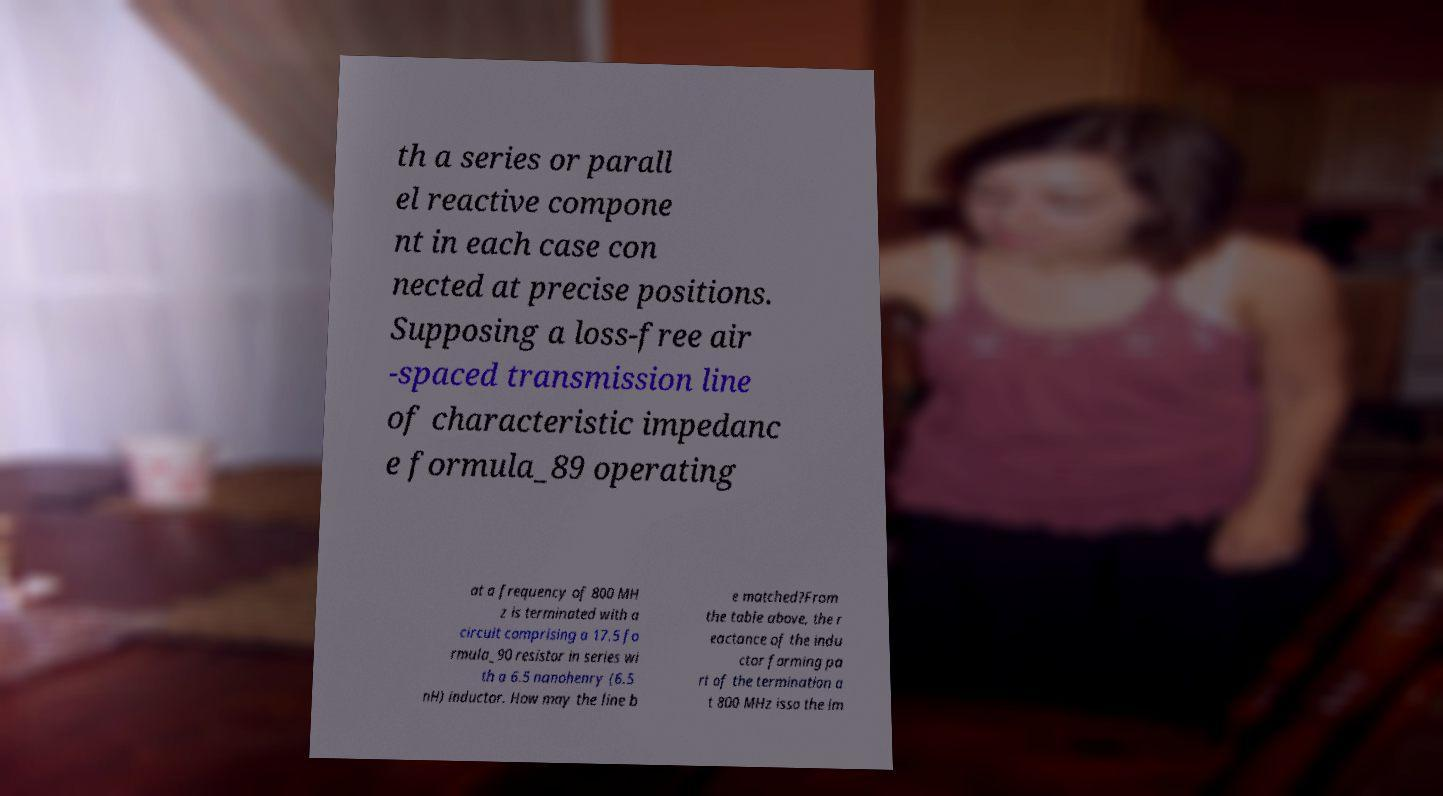Could you assist in decoding the text presented in this image and type it out clearly? th a series or parall el reactive compone nt in each case con nected at precise positions. Supposing a loss-free air -spaced transmission line of characteristic impedanc e formula_89 operating at a frequency of 800 MH z is terminated with a circuit comprising a 17.5 fo rmula_90 resistor in series wi th a 6.5 nanohenry (6.5 nH) inductor. How may the line b e matched?From the table above, the r eactance of the indu ctor forming pa rt of the termination a t 800 MHz isso the im 